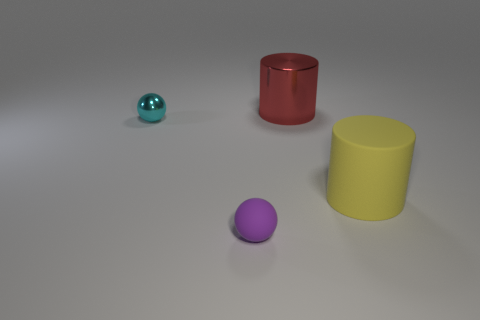Add 4 tiny green matte balls. How many objects exist? 8 Add 3 rubber balls. How many rubber balls are left? 4 Add 1 big brown metal cylinders. How many big brown metal cylinders exist? 1 Subtract 0 brown cylinders. How many objects are left? 4 Subtract all tiny cyan shiny spheres. Subtract all big yellow rubber cylinders. How many objects are left? 2 